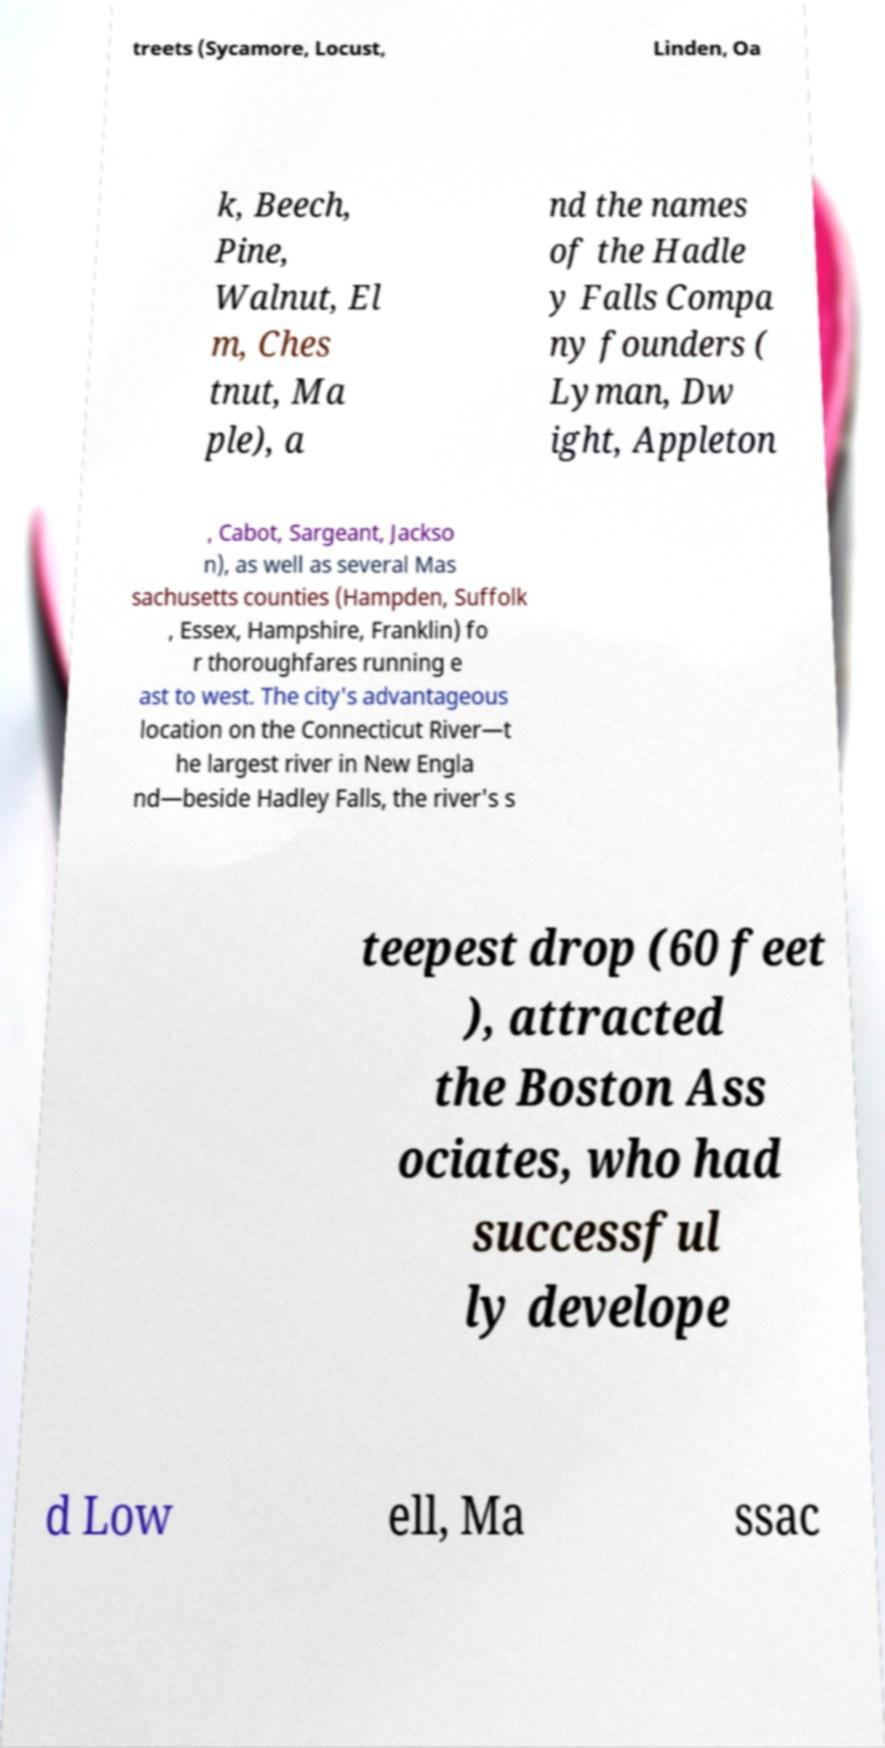There's text embedded in this image that I need extracted. Can you transcribe it verbatim? treets (Sycamore, Locust, Linden, Oa k, Beech, Pine, Walnut, El m, Ches tnut, Ma ple), a nd the names of the Hadle y Falls Compa ny founders ( Lyman, Dw ight, Appleton , Cabot, Sargeant, Jackso n), as well as several Mas sachusetts counties (Hampden, Suffolk , Essex, Hampshire, Franklin) fo r thoroughfares running e ast to west. The city's advantageous location on the Connecticut River—t he largest river in New Engla nd—beside Hadley Falls, the river's s teepest drop (60 feet ), attracted the Boston Ass ociates, who had successful ly develope d Low ell, Ma ssac 